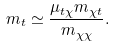Convert formula to latex. <formula><loc_0><loc_0><loc_500><loc_500>m _ { t } \simeq \frac { \mu _ { t \chi } m _ { \chi t } } { m _ { \chi \chi } } .</formula> 